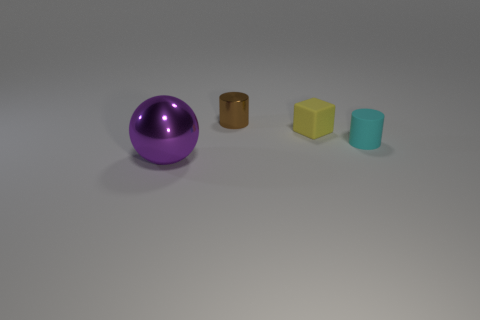Add 3 small metal cylinders. How many objects exist? 7 Subtract all blocks. How many objects are left? 3 Subtract all cyan cylinders. How many cylinders are left? 1 Subtract all yellow spheres. Subtract all gray cubes. How many spheres are left? 1 Subtract all big gray metal cubes. Subtract all tiny cyan objects. How many objects are left? 3 Add 1 cubes. How many cubes are left? 2 Add 1 yellow matte things. How many yellow matte things exist? 2 Subtract 0 green blocks. How many objects are left? 4 Subtract 1 blocks. How many blocks are left? 0 